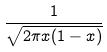<formula> <loc_0><loc_0><loc_500><loc_500>\frac { 1 } { \sqrt { 2 \pi x ( 1 - x ) } }</formula> 